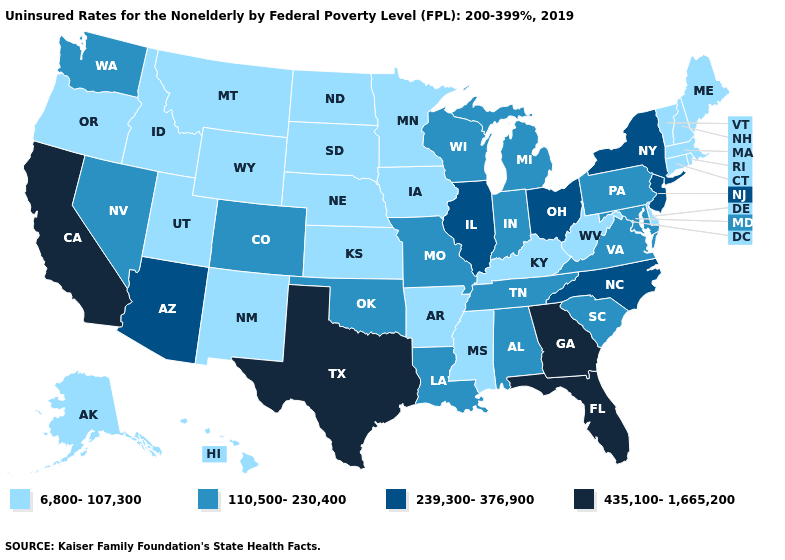What is the value of West Virginia?
Give a very brief answer. 6,800-107,300. What is the value of Massachusetts?
Answer briefly. 6,800-107,300. Does New York have a higher value than Arizona?
Give a very brief answer. No. What is the lowest value in the USA?
Write a very short answer. 6,800-107,300. Name the states that have a value in the range 239,300-376,900?
Quick response, please. Arizona, Illinois, New Jersey, New York, North Carolina, Ohio. Does Georgia have the highest value in the South?
Be succinct. Yes. Does Connecticut have the lowest value in the Northeast?
Keep it brief. Yes. Among the states that border Utah , does Arizona have the lowest value?
Short answer required. No. Name the states that have a value in the range 435,100-1,665,200?
Short answer required. California, Florida, Georgia, Texas. Name the states that have a value in the range 435,100-1,665,200?
Quick response, please. California, Florida, Georgia, Texas. Does the map have missing data?
Quick response, please. No. Does Wisconsin have a lower value than Illinois?
Answer briefly. Yes. Does the map have missing data?
Short answer required. No. Does Kentucky have the lowest value in the USA?
Quick response, please. Yes. 